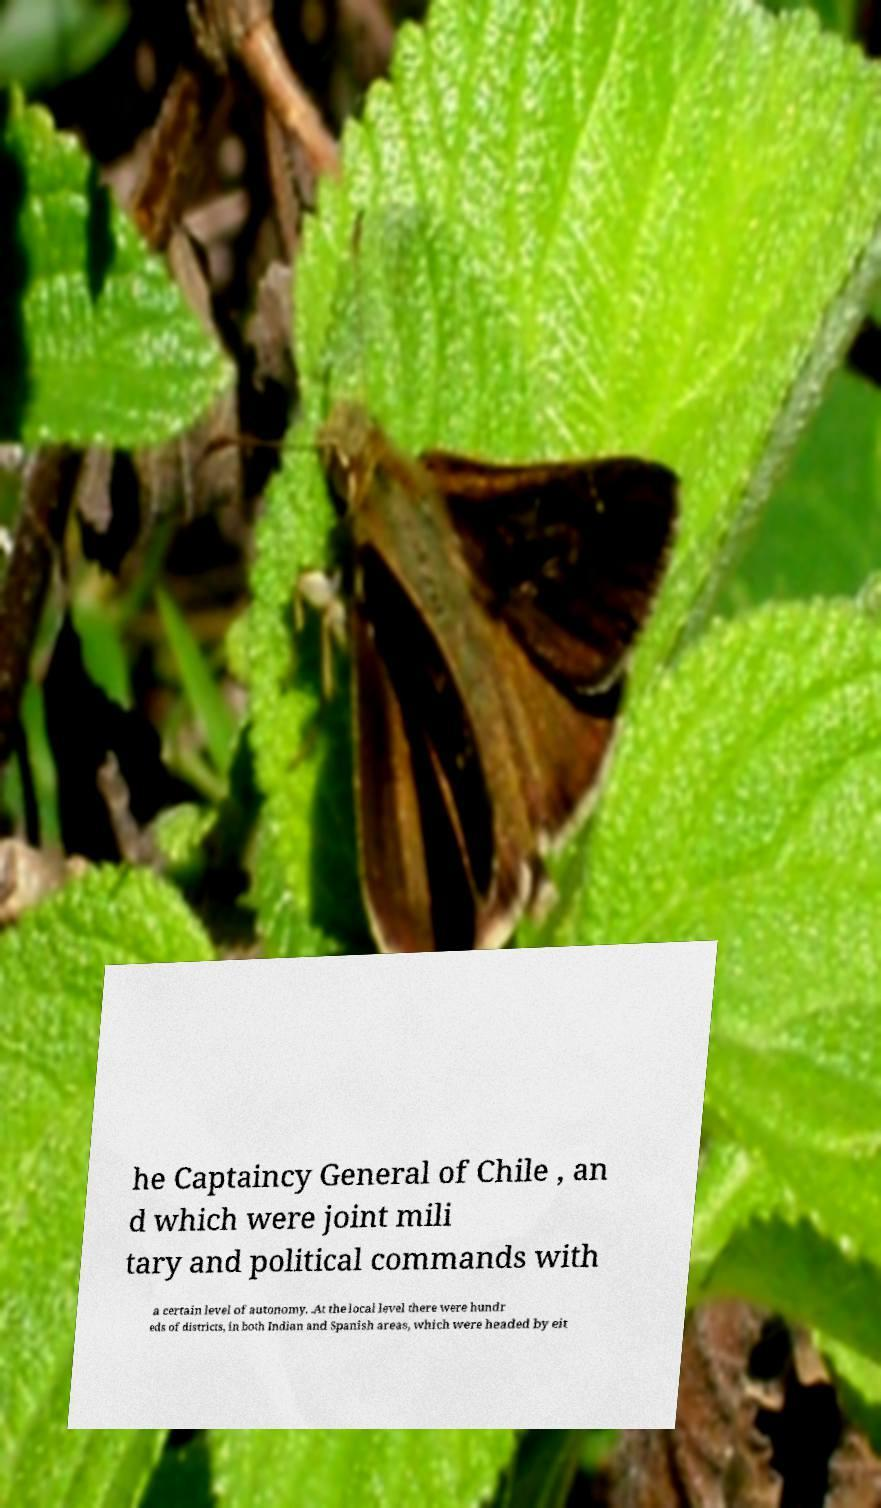Could you assist in decoding the text presented in this image and type it out clearly? he Captaincy General of Chile , an d which were joint mili tary and political commands with a certain level of autonomy. .At the local level there were hundr eds of districts, in both Indian and Spanish areas, which were headed by eit 